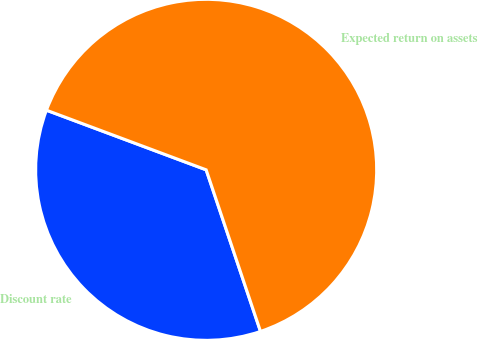Convert chart. <chart><loc_0><loc_0><loc_500><loc_500><pie_chart><fcel>Discount rate<fcel>Expected return on assets<nl><fcel>35.85%<fcel>64.15%<nl></chart> 